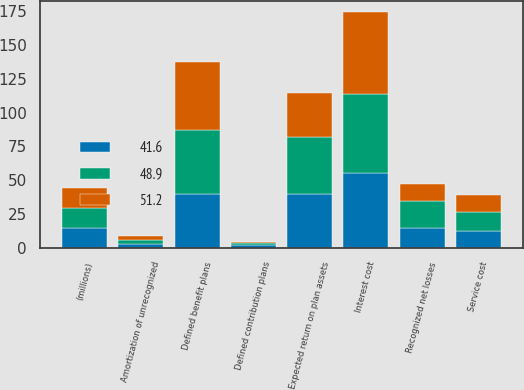Convert chart to OTSL. <chart><loc_0><loc_0><loc_500><loc_500><stacked_bar_chart><ecel><fcel>(millions)<fcel>Service cost<fcel>Interest cost<fcel>Expected return on plan assets<fcel>Amortization of unrecognized<fcel>Recognized net losses<fcel>Defined benefit plans<fcel>Defined contribution plans<nl><fcel>48.9<fcel>14.8<fcel>14.5<fcel>58.3<fcel>42.1<fcel>2.9<fcel>19.8<fcel>47.6<fcel>1.3<nl><fcel>41.6<fcel>14.8<fcel>12.1<fcel>55.6<fcel>39.8<fcel>2.9<fcel>14.8<fcel>39.8<fcel>1.8<nl><fcel>51.2<fcel>14.8<fcel>12.5<fcel>60.4<fcel>32.8<fcel>2.5<fcel>12.3<fcel>49.9<fcel>1.3<nl></chart> 